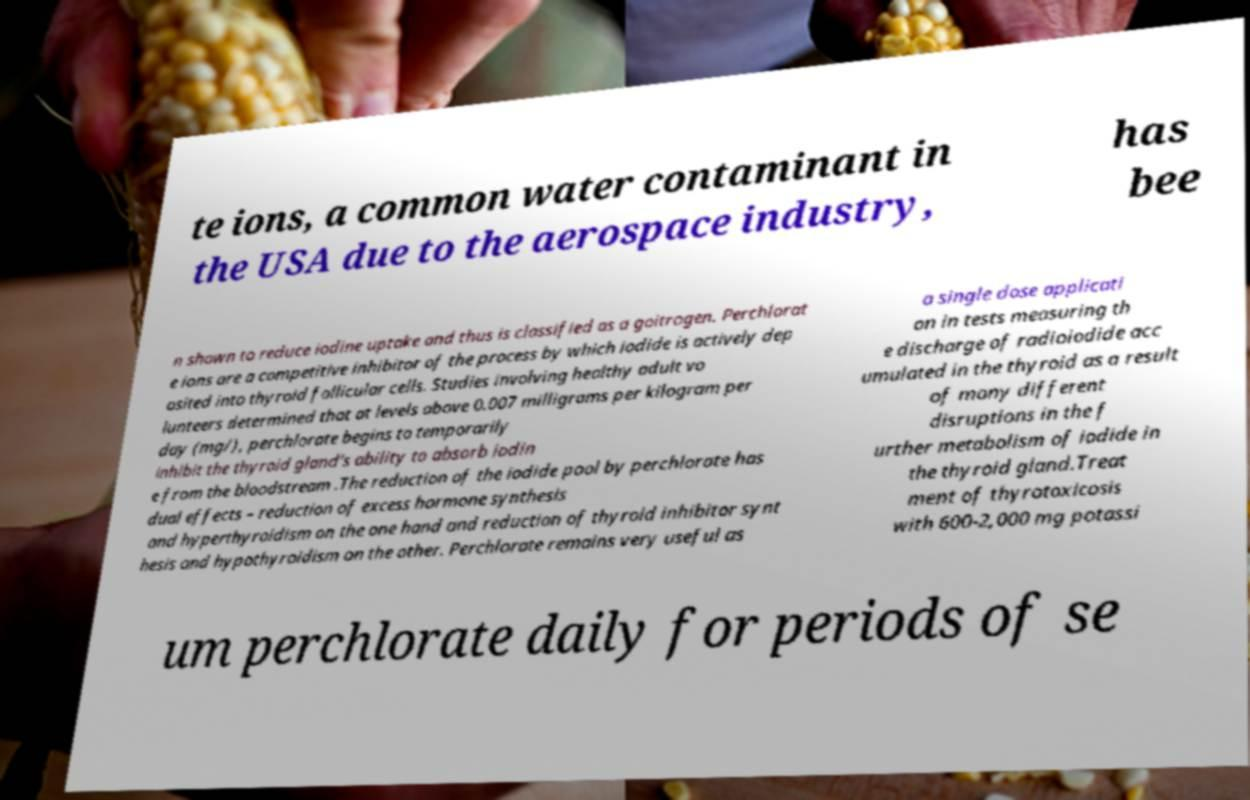What messages or text are displayed in this image? I need them in a readable, typed format. te ions, a common water contaminant in the USA due to the aerospace industry, has bee n shown to reduce iodine uptake and thus is classified as a goitrogen. Perchlorat e ions are a competitive inhibitor of the process by which iodide is actively dep osited into thyroid follicular cells. Studies involving healthy adult vo lunteers determined that at levels above 0.007 milligrams per kilogram per day (mg/), perchlorate begins to temporarily inhibit the thyroid gland’s ability to absorb iodin e from the bloodstream .The reduction of the iodide pool by perchlorate has dual effects – reduction of excess hormone synthesis and hyperthyroidism on the one hand and reduction of thyroid inhibitor synt hesis and hypothyroidism on the other. Perchlorate remains very useful as a single dose applicati on in tests measuring th e discharge of radioiodide acc umulated in the thyroid as a result of many different disruptions in the f urther metabolism of iodide in the thyroid gland.Treat ment of thyrotoxicosis with 600-2,000 mg potassi um perchlorate daily for periods of se 